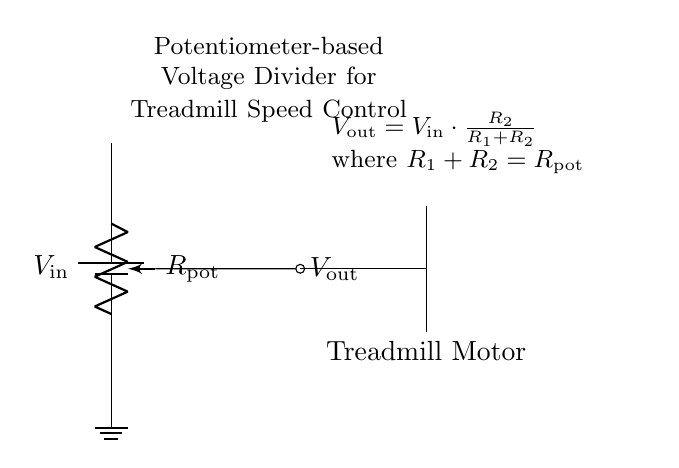What is the input voltage in this circuit? The circuit includes a labeled battery with a notation for the input voltage, $V_{\text{in}}$, connected at the top.
Answer: V_in What is the component used to control the speed of the treadmill? The diagram shows a potentiometer labeled $R_{\text{pot}}$ connected in the circuit, indicating it is used for adjusting resistance, thus controlling speed.
Answer: R_pot What is the relationship between the output voltage and the input voltage in this circuit? The circuit has a formula indicating that the output voltage, $V_{\text{out}}$, is calculated as a fraction of the input voltage, dependent on the resistances in the potentiometer and their arrangement.
Answer: V_out = V_in * (R_2 / (R_1 + R_2)) How many terminals does the potentiometer have? A potentiometer typically has three terminals, one at each end and one for the wiper. This circuit symbol shows the pot with a single wiper terminal.
Answer: Three What is the function of the ground symbol in this circuit? The ground symbol indicates the reference point for the voltages in the circuit, establishing a common return path for current, which in this case connects to the bottom of the potentiometer.
Answer: Reference point If the potentiometer resistance is increased, what happens to the output voltage? An increase in potentiometer resistance means that a larger portion of the input voltage will appear across the load (the treadmill motor), thereby increasing the output voltage.
Answer: Increases 